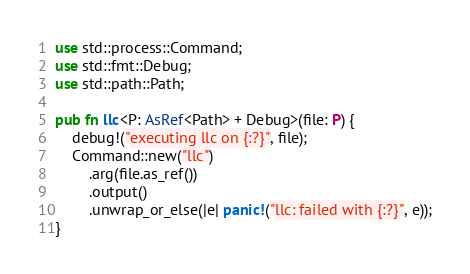<code> <loc_0><loc_0><loc_500><loc_500><_Rust_>use std::process::Command;
use std::fmt::Debug;
use std::path::Path;

pub fn llc<P: AsRef<Path> + Debug>(file: P) {
    debug!("executing llc on {:?}", file);
    Command::new("llc")
        .arg(file.as_ref())
        .output()
        .unwrap_or_else(|e| panic!("llc: failed with {:?}", e));
}
</code> 